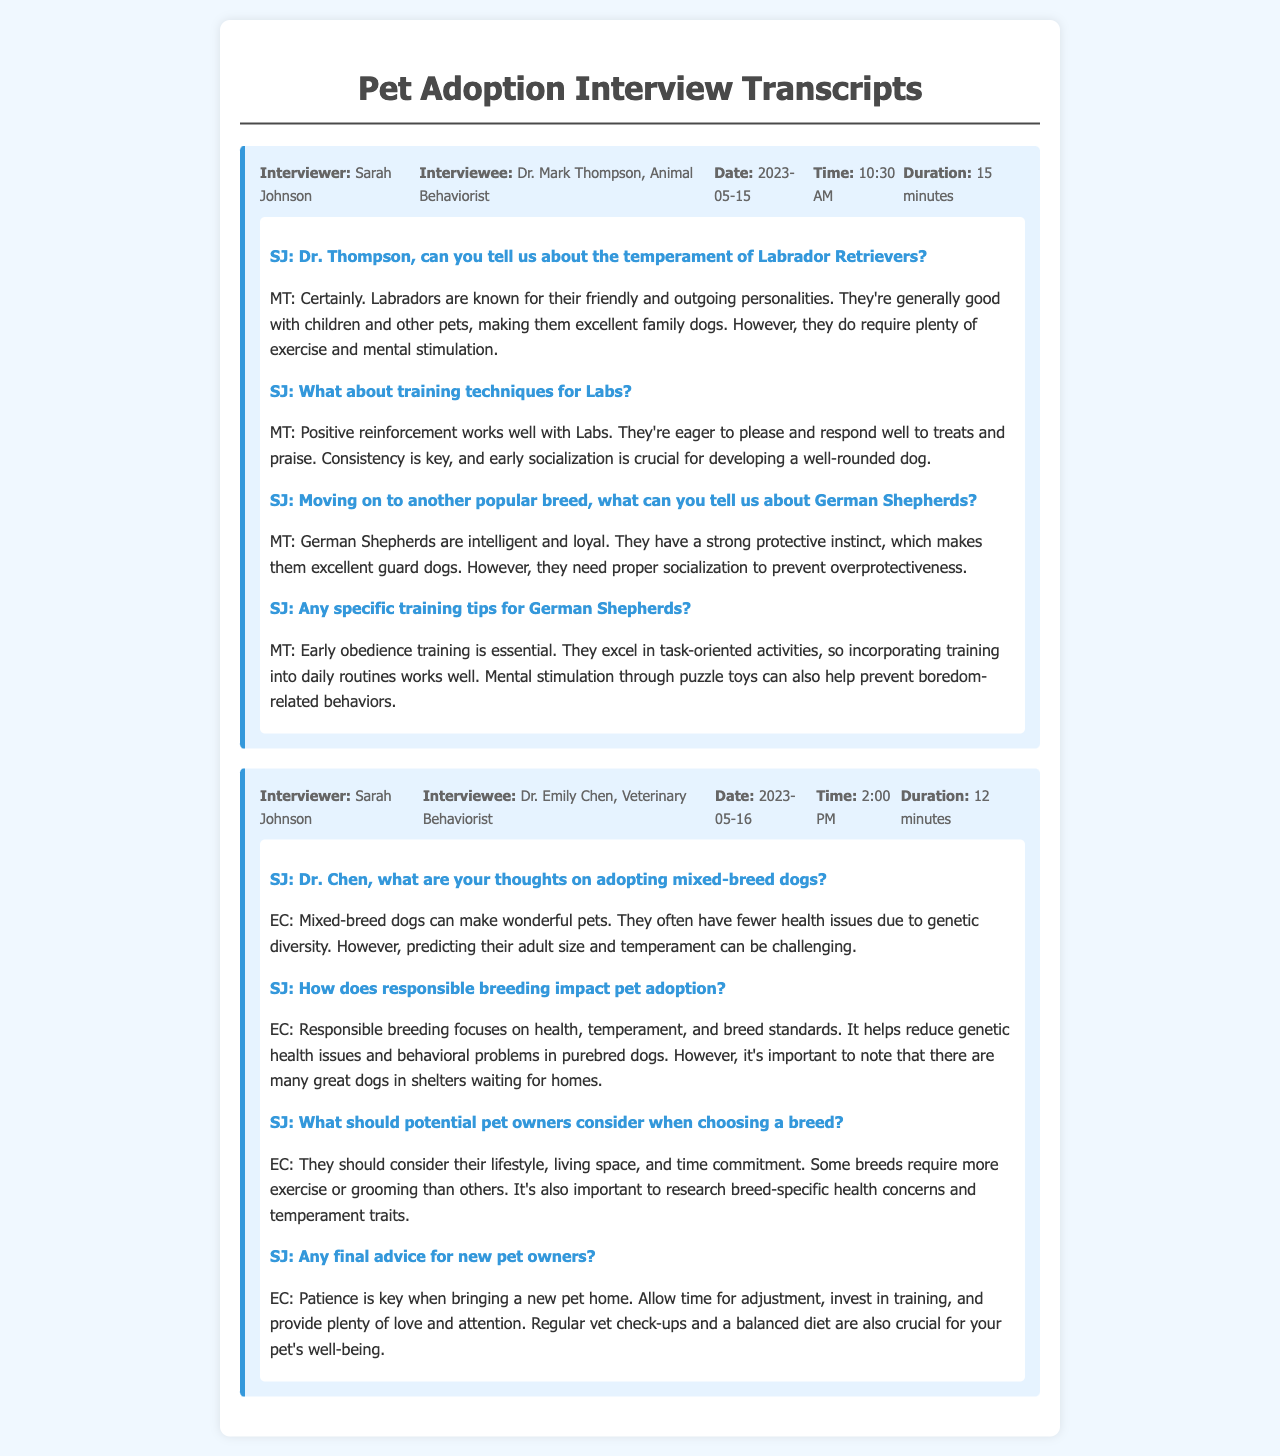What is the name of the interviewer? The interviewer's name is Sarah Johnson, as mentioned in the transcripts.
Answer: Sarah Johnson Who was interviewed on May 15, 2023? The interview conducted on this date was with Dr. Mark Thompson, an Animal Behaviorist.
Answer: Dr. Mark Thompson What breed is known for being friendly and good with children? The breed that is known for its friendly and outgoing personality, especially with children, is the Labrador Retriever.
Answer: Labrador Retriever What training technique is emphasized for German Shepherds? Early obedience training is essential for German Shepherds, according to Dr. Mark Thompson.
Answer: Early obedience training What advantage do mixed-breed dogs often have? Mixed-breed dogs often have fewer health issues due to genetic diversity, as stated by Dr. Emily Chen.
Answer: Fewer health issues What should potential pet owners consider when choosing a breed? Potential pet owners should consider their lifestyle, living space, and time commitment when choosing a breed, according to Dr. Emily Chen.
Answer: Lifestyle, living space, time commitment What is advised for new pet owners regarding their pet's well-being? Dr. Emily Chen advises that regular vet check-ups and a balanced diet are crucial for a pet's well-being.
Answer: Regular vet check-ups, balanced diet What is the interview duration with Dr. Emily Chen? The duration of the interview with Dr. Emily Chen was 12 minutes.
Answer: 12 minutes 